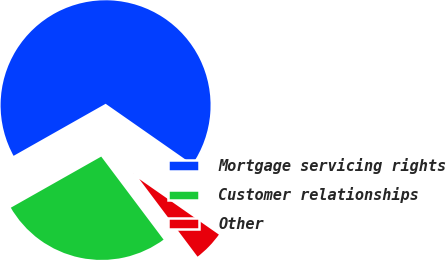Convert chart to OTSL. <chart><loc_0><loc_0><loc_500><loc_500><pie_chart><fcel>Mortgage servicing rights<fcel>Customer relationships<fcel>Other<nl><fcel>67.89%<fcel>27.06%<fcel>5.05%<nl></chart> 